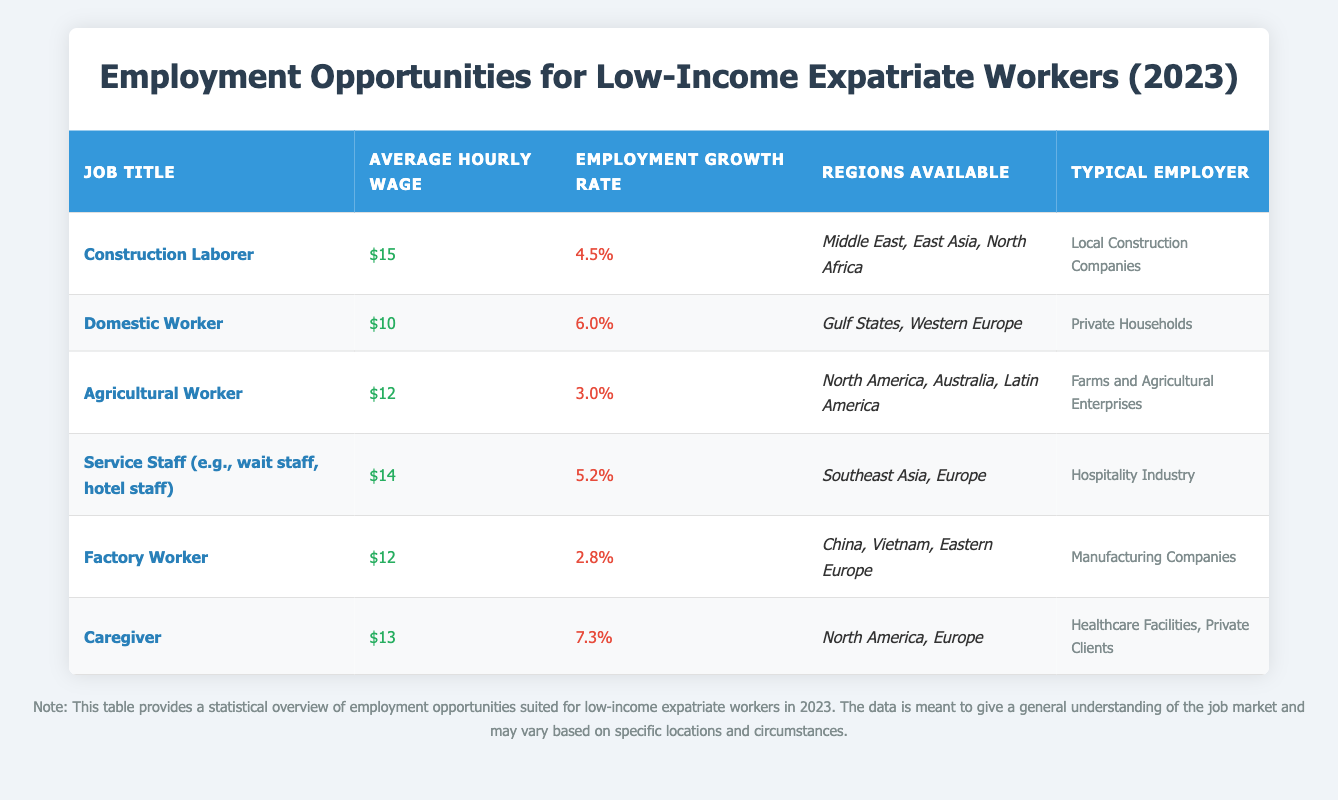What is the average hourly wage for a Domestic Worker? The table lists the average hourly wage for each job title, and for Domestic Worker, it shows $10.
Answer: $10 Which job has the highest employment growth rate? The employment growth rates are provided in the table, and the highest rate is 7.3% for the Caregiver position.
Answer: 7.3% How many regions are available for Agricultural Workers? The table indicates that Agricultural Workers are available in three regions: North America, Australia, and Latin America.
Answer: 3 Is the average hourly wage for Service Staff higher than that of Factory Workers? The table shows the average hourly wage for Service Staff as $14 and for Factory Workers as $12. Since $14 is greater than $12, the statement is true.
Answer: Yes What is the difference in average hourly wage between Construction Laborers and Caregivers? The average hourly wage for Construction Laborers is $15, and for Caregivers, it is $13. The difference is calculated as $15 - $13 = $2.
Answer: $2 In which regions can Domestic Workers find employment? The regions available for Domestic Workers are stated in the table as Gulf States and Western Europe.
Answer: Gulf States, Western Europe Calculate the average employment growth rate of all jobs listed. To find the average growth rate, add all the growth rates: 4.5 + 6.0 + 3.0 + 5.2 + 2.8 + 7.3 = 28.8. Then, divide by the number of job titles, which is 6. So, 28.8 / 6 = 4.8%.
Answer: 4.8% Does the Factory Worker position have a higher average hourly wage compared to Agricultural Workers? The average hourly wage for Factory Workers is $12, while for Agricultural Workers, it is $12 as well. Since they are equal, the statement is false.
Answer: No What are the typical employers for Service Staff? The typical employers for Service Staff, as noted in the table, is the Hospitality Industry.
Answer: Hospitality Industry 